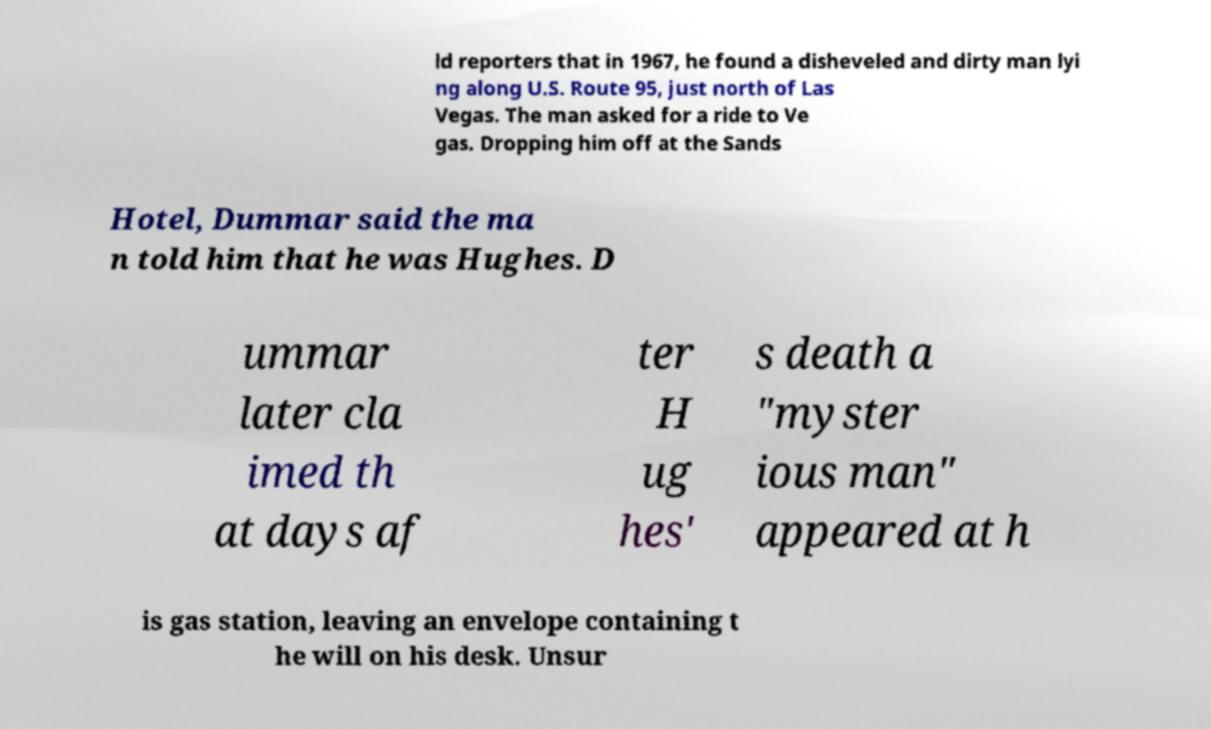Could you assist in decoding the text presented in this image and type it out clearly? ld reporters that in 1967, he found a disheveled and dirty man lyi ng along U.S. Route 95, just north of Las Vegas. The man asked for a ride to Ve gas. Dropping him off at the Sands Hotel, Dummar said the ma n told him that he was Hughes. D ummar later cla imed th at days af ter H ug hes' s death a "myster ious man" appeared at h is gas station, leaving an envelope containing t he will on his desk. Unsur 